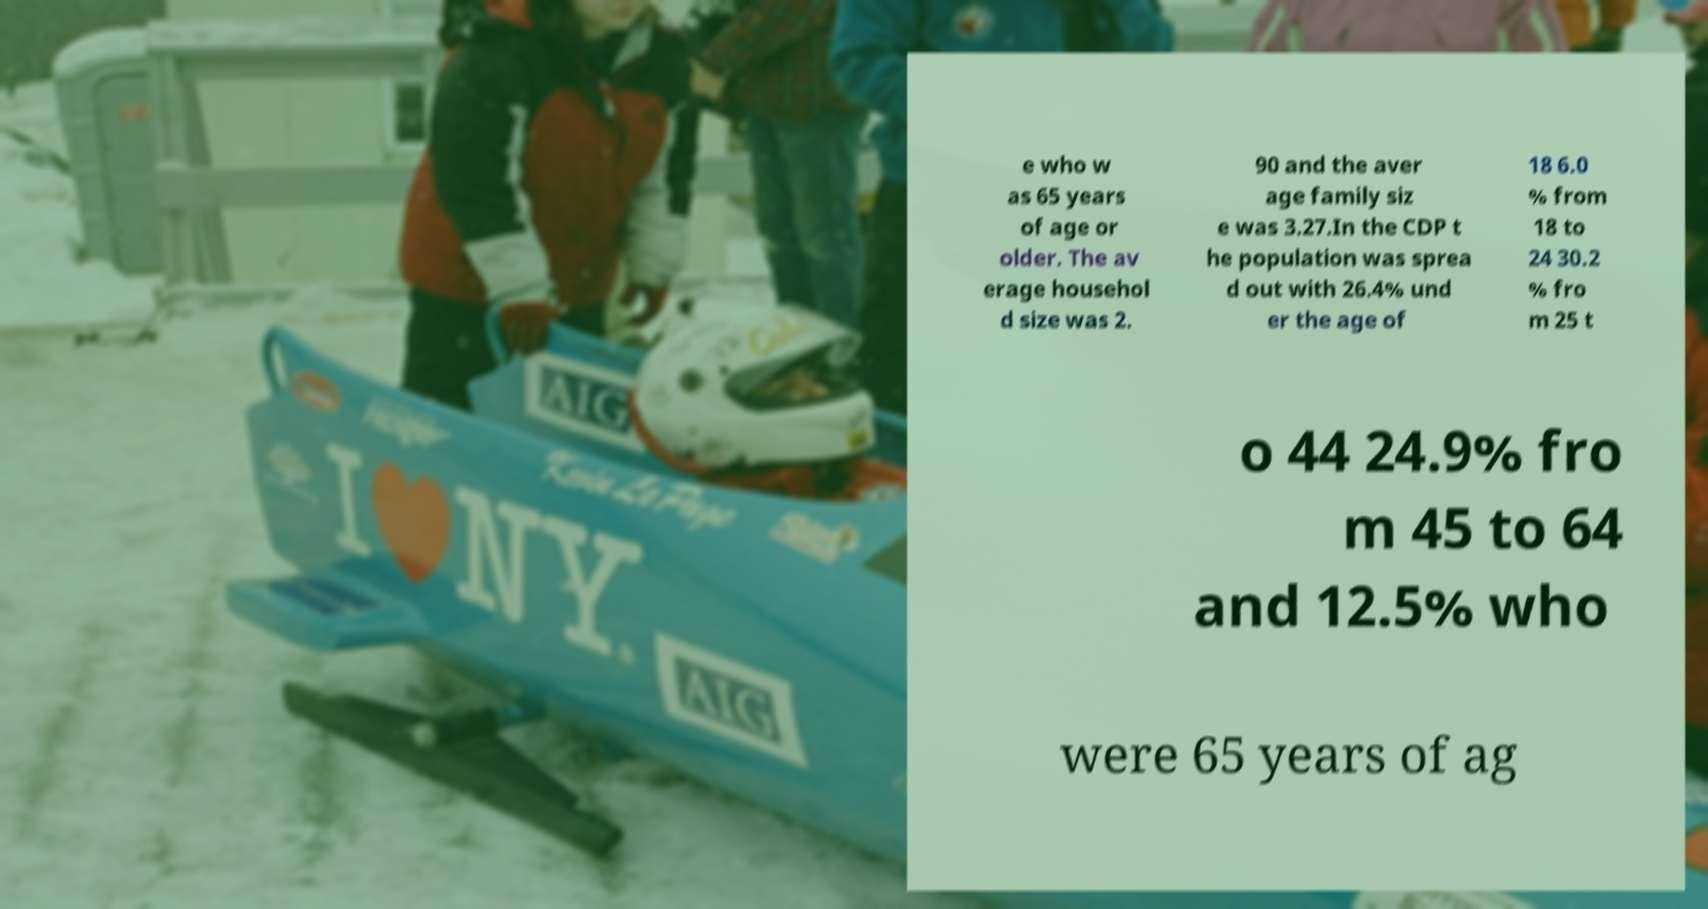Could you assist in decoding the text presented in this image and type it out clearly? e who w as 65 years of age or older. The av erage househol d size was 2. 90 and the aver age family siz e was 3.27.In the CDP t he population was sprea d out with 26.4% und er the age of 18 6.0 % from 18 to 24 30.2 % fro m 25 t o 44 24.9% fro m 45 to 64 and 12.5% who were 65 years of ag 